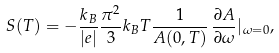Convert formula to latex. <formula><loc_0><loc_0><loc_500><loc_500>S ( T ) = - \frac { k _ { B } } { | e | } \frac { \pi ^ { 2 } } { 3 } k _ { B } T \frac { 1 } { A ( 0 , T ) } \, \frac { \partial A } { \partial \omega } | _ { \omega = 0 } ,</formula> 